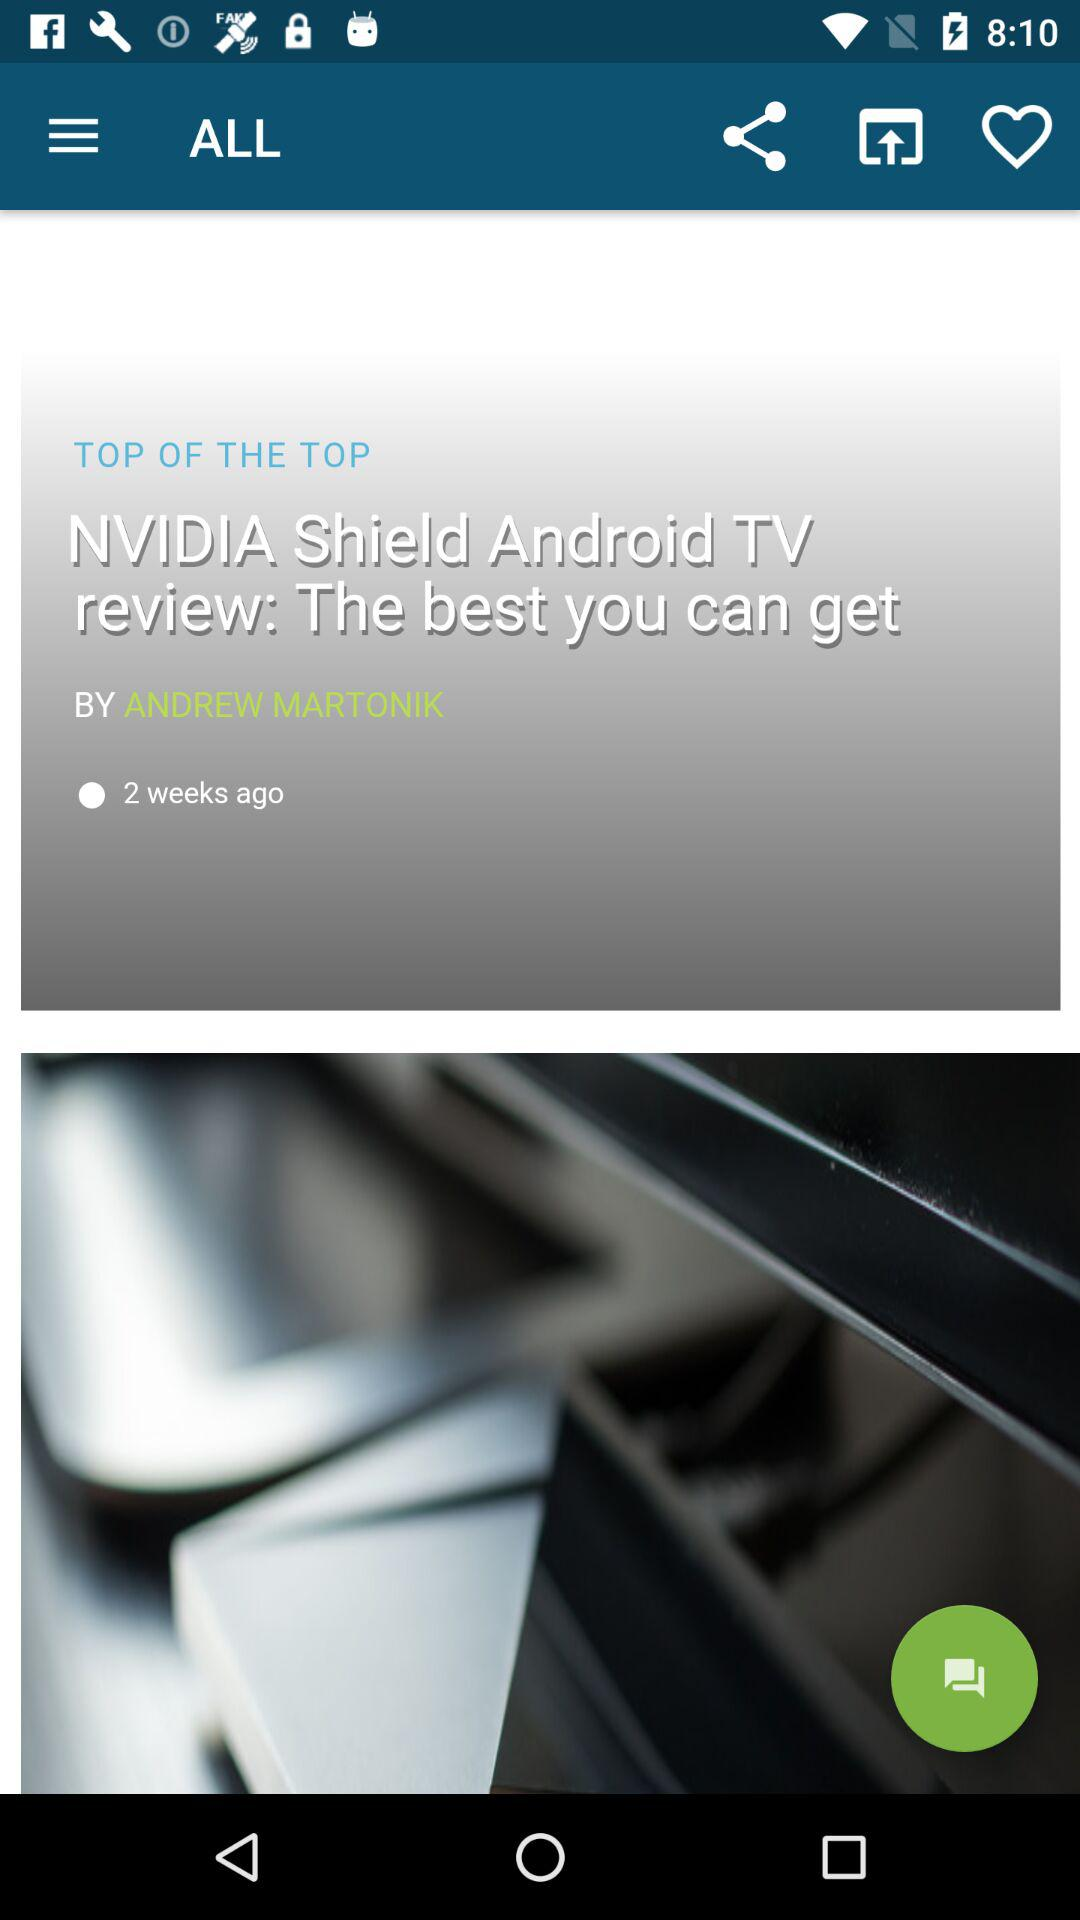Who is the author? The author is Andrew Martonik. 